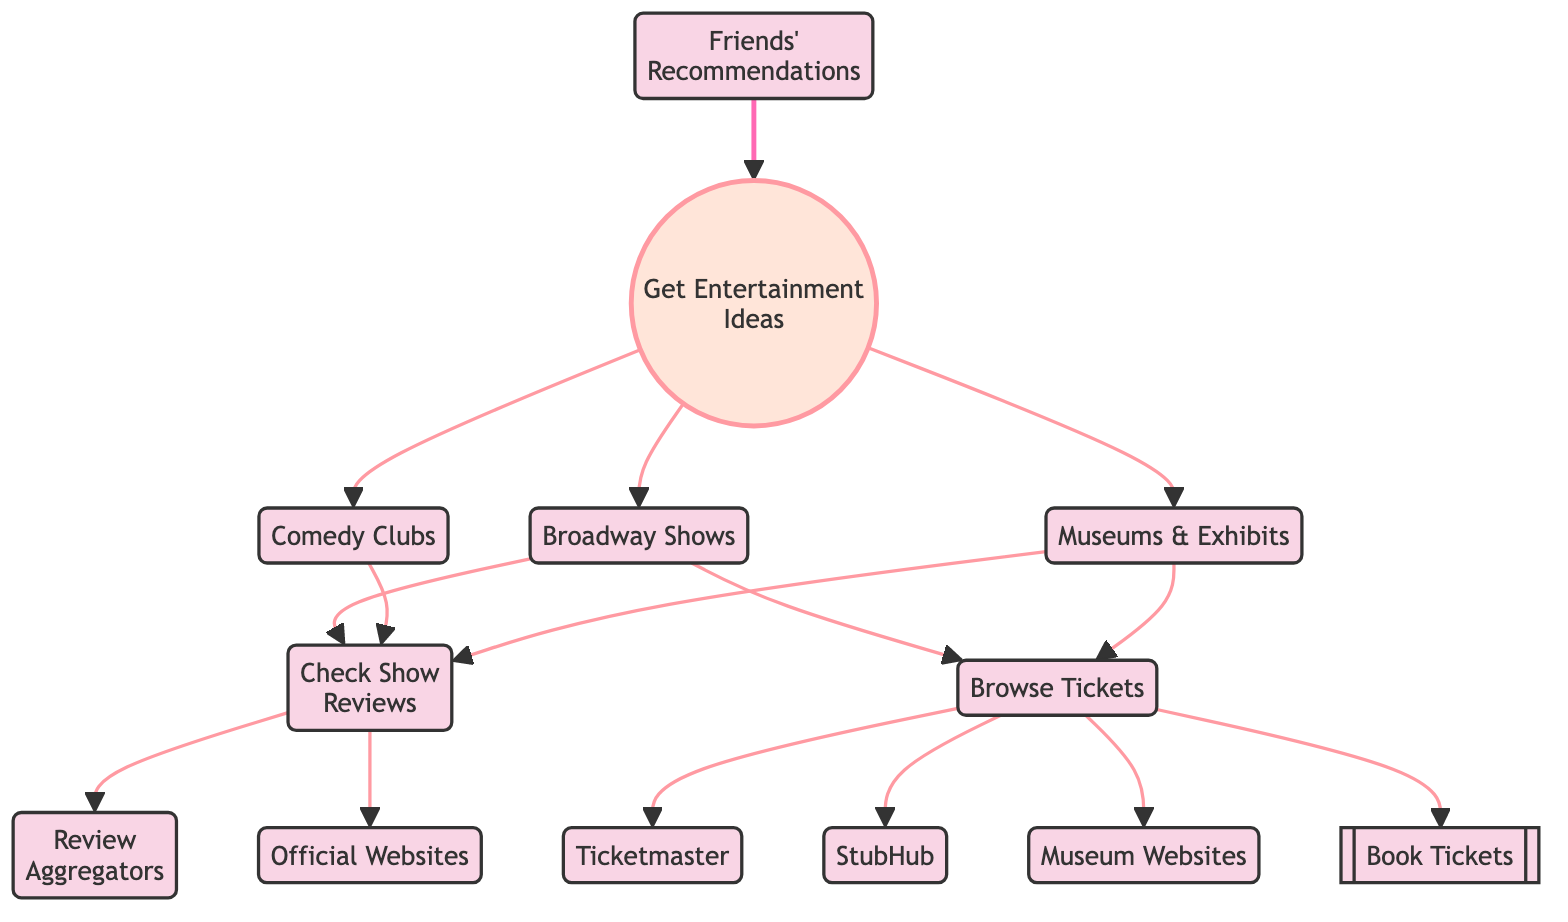What's the total number of nodes in the diagram? There are 13 distinct nodes listed in the diagram, each representing a step or element of the weekend entertainment planning process.
Answer: 13 Which node represents booking tickets? The node labeled “Book Tickets” represents the action of booking tickets and is connected to multiple steps in the flow of finding and purchasing entertainment tickets.
Answer: Book Tickets What are three sources for getting entertainment ideas? The diagram shows that "Broadway Shows," "Comedy Clubs," and "Museums & Exhibits" are three sources a user can explore to get entertainment ideas.
Answer: Broadway Shows, Comedy Clubs, Museums & Exhibits How many types of ticket platforms are mentioned? The diagram lists three platforms: "Ticketmaster," "StubHub," and "Museum Websites," which are all sources for purchasing tickets.
Answer: 3 What must you do before you can book tickets? To book tickets, you must first browse tickets, as indicated in the flow from "Browse Tickets" to "Book Tickets."
Answer: Browse Tickets Which node connects to both “Check Show Reviews” and “Browse Tickets”? The nodes "Broadway Shows," "Comedy Clubs," and "Museums & Exhibits" all connect to “Check Show Reviews” and lead to “Browse Tickets,” indicating the process that ties review checking to ticket browsing.
Answer: Broadway Shows, Comedy Clubs, Museums & Exhibits What is the relationship between "Check Show Reviews" and "Review Aggregators"? "Check Show Reviews" directly connects to "Review Aggregators," meaning that reviewing these aggregators is a step taken after checking the show reviews.
Answer: Direct connection Name a type of recommendation that can be utilized to get entertainment ideas. "Friends' Recommendations" is identified as a type of recommendation that can be used to gather entertainment ideas in the diagram.
Answer: Friends' Recommendations Which node does “Browse Tickets” lead to before booking? “Browse Tickets” leads directly to “Book Tickets,” indicating it's a necessary step to take before ticket purchasing.
Answer: Book Tickets 